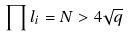<formula> <loc_0><loc_0><loc_500><loc_500>\prod l _ { i } = N > 4 \sqrt { q }</formula> 